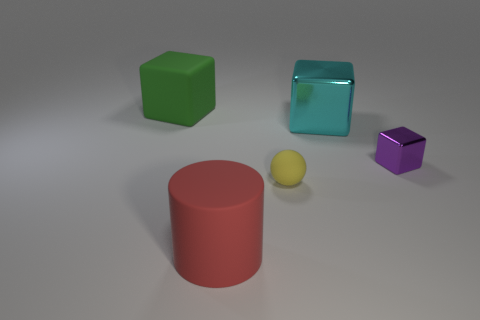Can you tell me the number of objects and their shapes in the image? Certainly! In the image, there are four objects. Starting from the left, there's a green cube, a matte red cylinder, a small yellow sphere, and a purple cube that is smaller in size compared to the green one. The transparent blue object to the right side is a cube as well. 